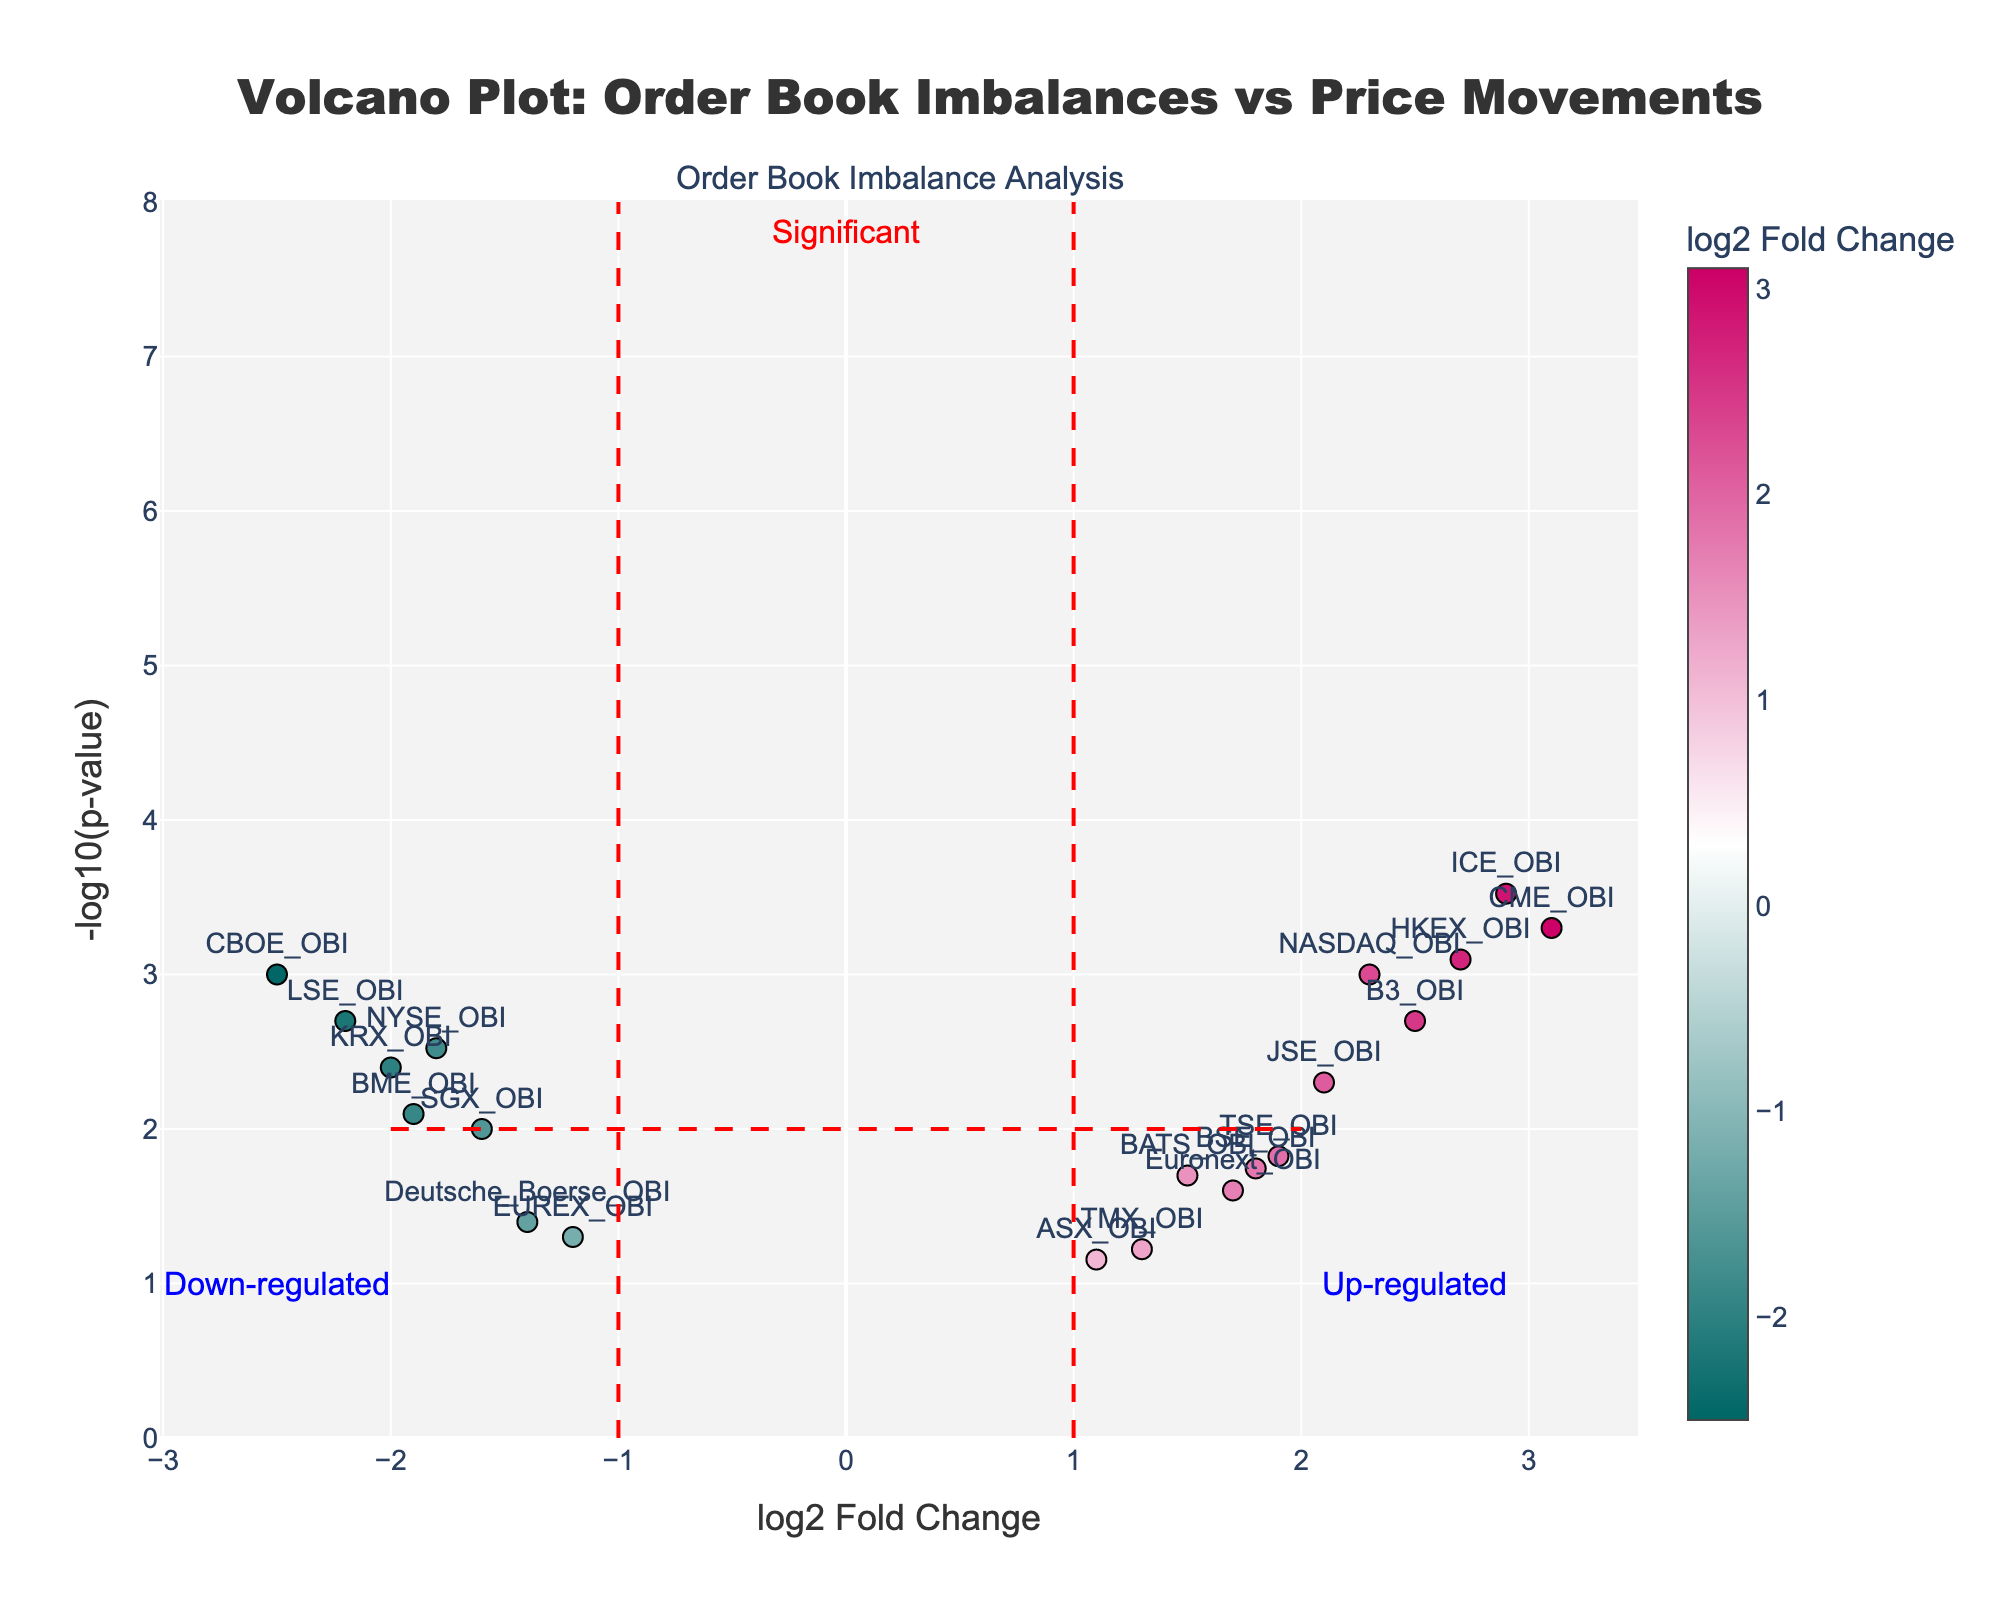What is the title of the volcano plot? The title is prominently displayed at the top of the figure. Reading it will tell us the main focus of the plot.
Answer: Volcano Plot: Order Book Imbalances vs Price Movements How many data points are depicted in the volcano plot? By counting the markers or annotations in the scatter plot, we can determine the total number of data points.
Answer: 19 Which order book imbalance has the highest log2 fold change? The highest log2 fold change can be found by identifying the point farthest to the right on the x-axis.
Answer: CME_OBI Which data point has the smallest p-value? The smallest p-value is indicated by the highest -log10(p-value) value on the y-axis.
Answer: ICE_OBI Where is the "Significant" annotation located in terms of log2 fold change and -log10(p-value)? The annotation is positioned near a specific log2 fold change and -log10(p-value) value. By locating its position relative to the axes, we can find its coordinates.
Answer: At log2 fold change = 0 and -log10(p-value) = 7.8 How many order book imbalances are considered significantly up-regulated (log2 fold change > 1 and -log10(p-value) > 2)? By filtering the data points that meet both criteria, we can count the number of such points.
Answer: 7 Which order book imbalances show negative log2 fold changes but are not considered significant? To find these, we look for data points with negative log2 fold change values that fall below the -log10(p-value) threshold of 2.
Answer: Deutsche_Boerse_OBI, EUREX_OBI, and SGX_OBI Among the significant data points, which has the smallest log2 fold change? From the subset of significant points (-log10(p-value) > 2), we select the one with the smallest log2 fold change value.
Answer: NYSE_OBI By how much does the -log10(p-value) of ICE_OBI exceed that of HKEX_OBI? We find the -log10(p-value) values for both data points and calculate the difference.
Answer: 0.1 What does the red dashed horizontal line in the plot signify? The horizontal line represents a specific -log10(p-value) threshold for significance, often used to identify important data points.
Answer: -log10(p-value) = 2 